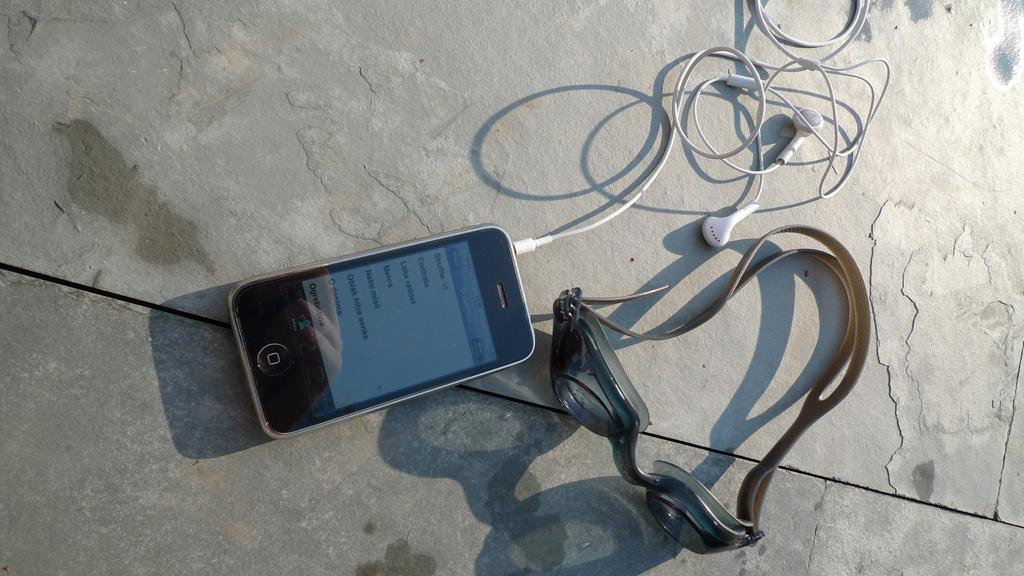<image>
Write a terse but informative summary of the picture. A cell phone with a list of songs set to "Shuffle" 